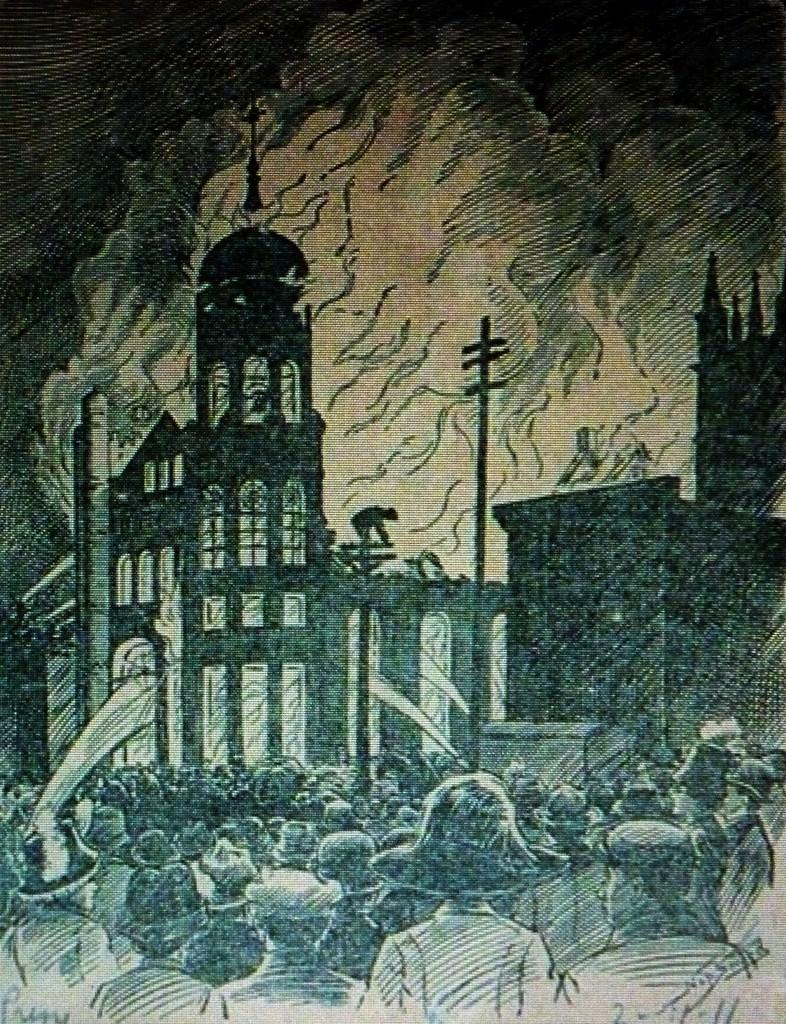What is depicted in the image? The image contains a sketch of buildings. Are there any human figures in the sketch? Yes, there are people standing in the sketch. How would you classify this image? The image is considered a piece of art. What type of game is being played by the people in the image? There is no game being played in the image; it is a sketch of buildings with people standing in it. Can you see any caps worn by the people in the image? There is no information about caps or any other clothing items worn by the people in the image. 